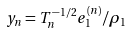<formula> <loc_0><loc_0><loc_500><loc_500>y _ { n } = T _ { n } ^ { - 1 / 2 } e _ { 1 } ^ { ( n ) } / \rho _ { 1 }</formula> 